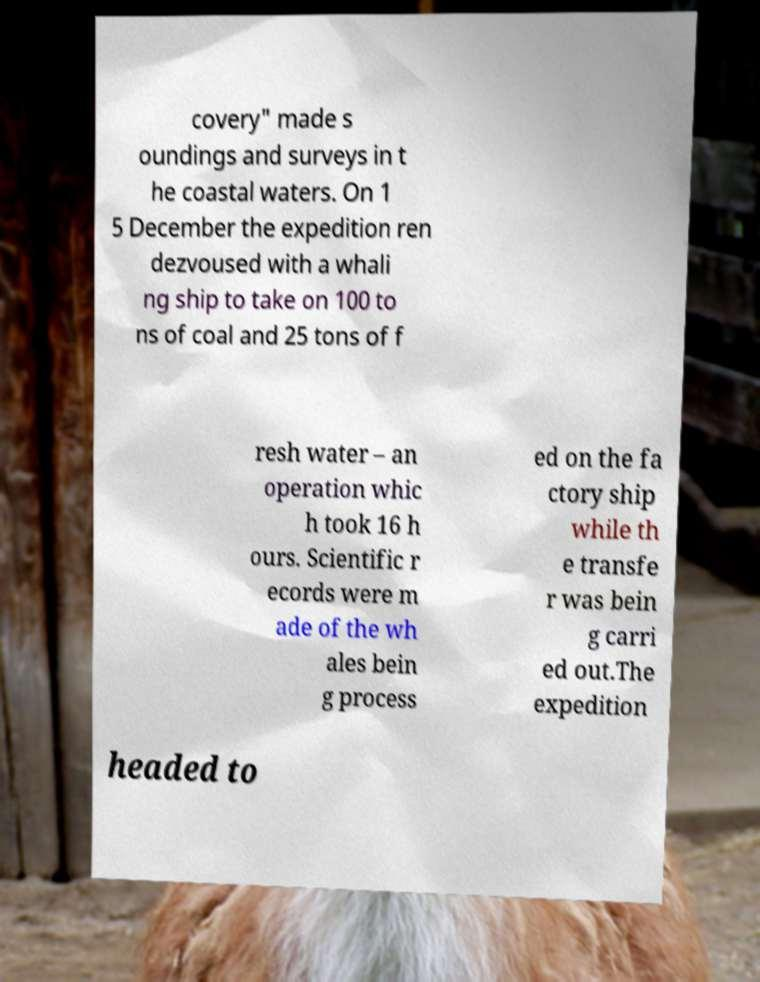Can you accurately transcribe the text from the provided image for me? covery" made s oundings and surveys in t he coastal waters. On 1 5 December the expedition ren dezvoused with a whali ng ship to take on 100 to ns of coal and 25 tons of f resh water – an operation whic h took 16 h ours. Scientific r ecords were m ade of the wh ales bein g process ed on the fa ctory ship while th e transfe r was bein g carri ed out.The expedition headed to 